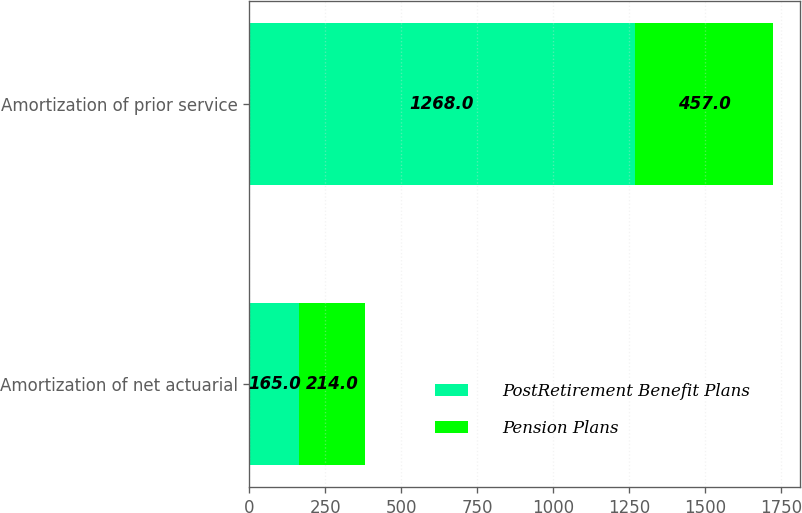<chart> <loc_0><loc_0><loc_500><loc_500><stacked_bar_chart><ecel><fcel>Amortization of net actuarial<fcel>Amortization of prior service<nl><fcel>PostRetirement Benefit Plans<fcel>165<fcel>1268<nl><fcel>Pension Plans<fcel>214<fcel>457<nl></chart> 